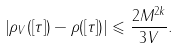Convert formula to latex. <formula><loc_0><loc_0><loc_500><loc_500>\left | \rho _ { V } ( \left [ \tau \right ] ) - \rho ( \left [ \tau \right ] ) \right | \leqslant \frac { 2 M ^ { 2 k } } { 3 V } .</formula> 